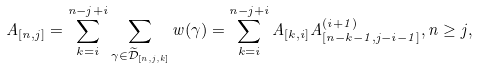Convert formula to latex. <formula><loc_0><loc_0><loc_500><loc_500>A _ { [ n , j ] } = \sum _ { k = i } ^ { n - j + i } \sum _ { \gamma \in \widetilde { \mathcal { D } } _ { [ n , j , k ] } } w ( \gamma ) = \sum _ { k = i } ^ { n - j + i } A _ { [ k , i ] } A _ { [ n - k - 1 , j - i - 1 ] } ^ { ( i + 1 ) } , n \geq j ,</formula> 